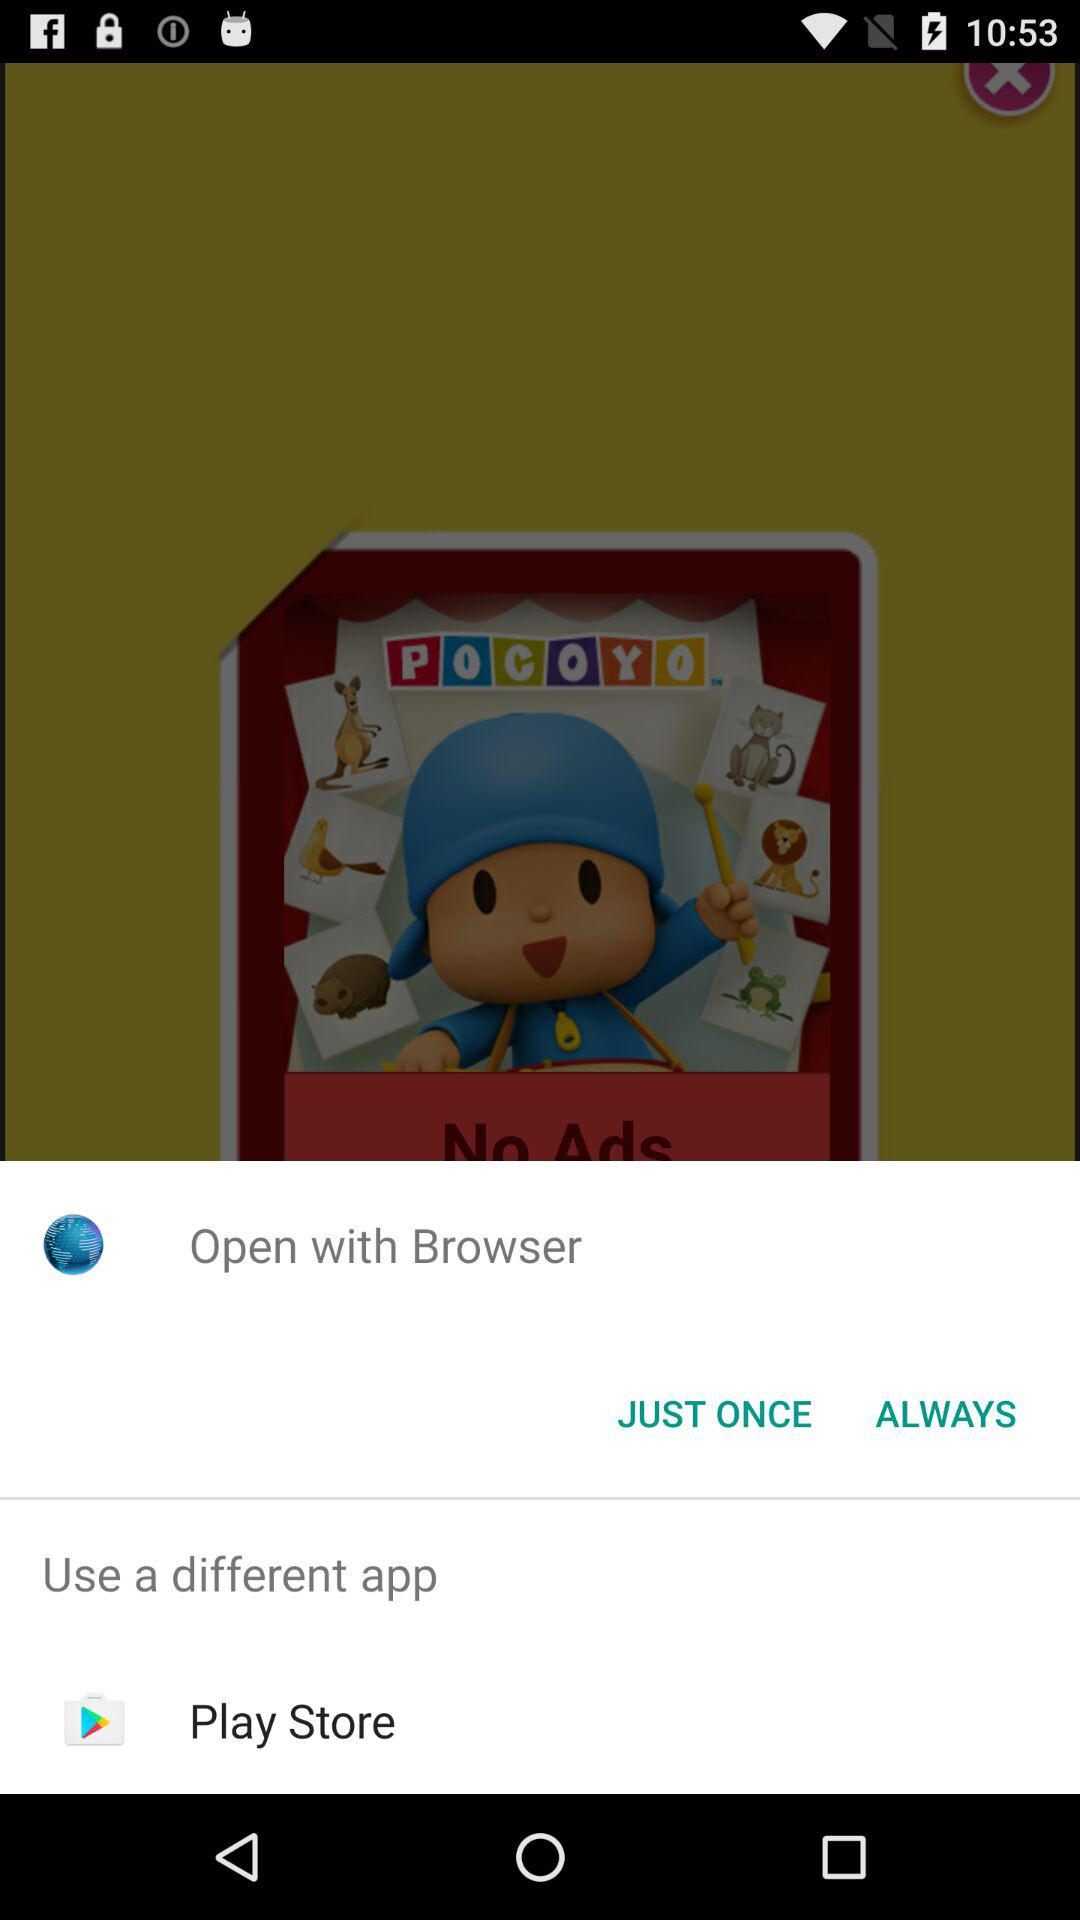Through which app can I open it? You can open it through the "Play Store" app. 